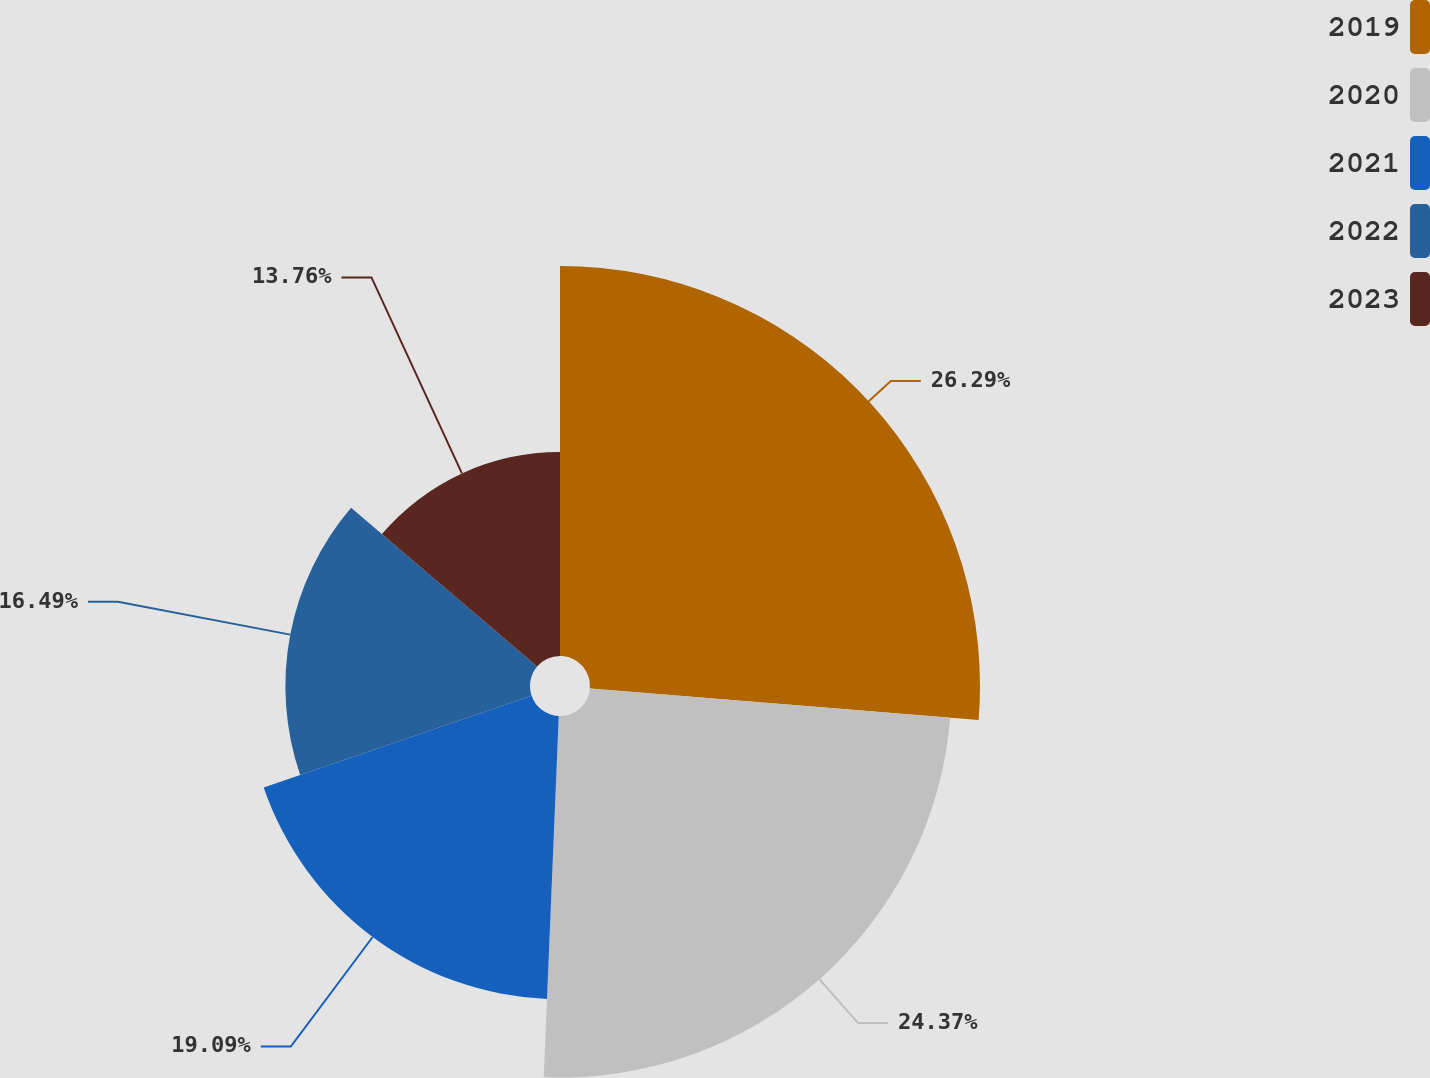Convert chart. <chart><loc_0><loc_0><loc_500><loc_500><pie_chart><fcel>2019<fcel>2020<fcel>2021<fcel>2022<fcel>2023<nl><fcel>26.29%<fcel>24.37%<fcel>19.09%<fcel>16.49%<fcel>13.76%<nl></chart> 